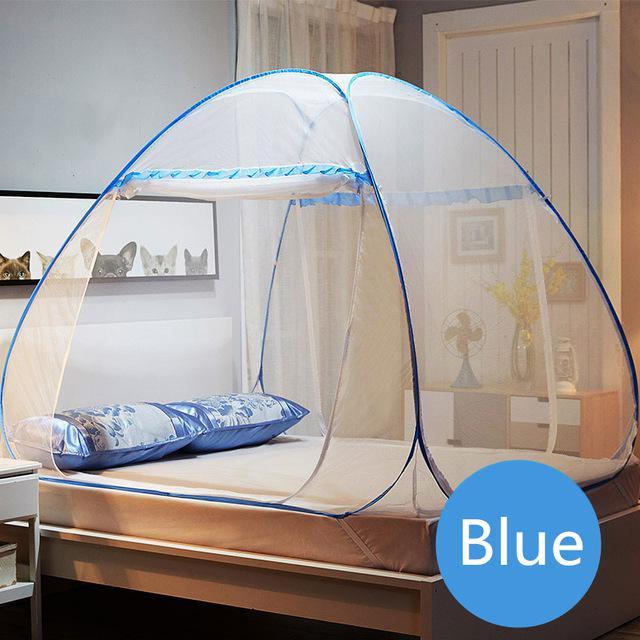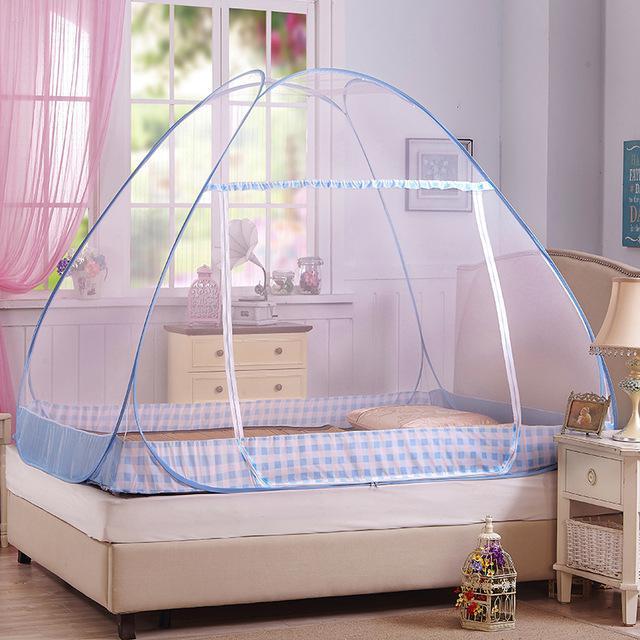The first image is the image on the left, the second image is the image on the right. Evaluate the accuracy of this statement regarding the images: "Each image shows a canopy with a dome top and trim in a shade of blue over a bed with no one on it.". Is it true? Answer yes or no. Yes. The first image is the image on the left, the second image is the image on the right. Examine the images to the left and right. Is the description "One bed net has a fabric bottom trim." accurate? Answer yes or no. Yes. 